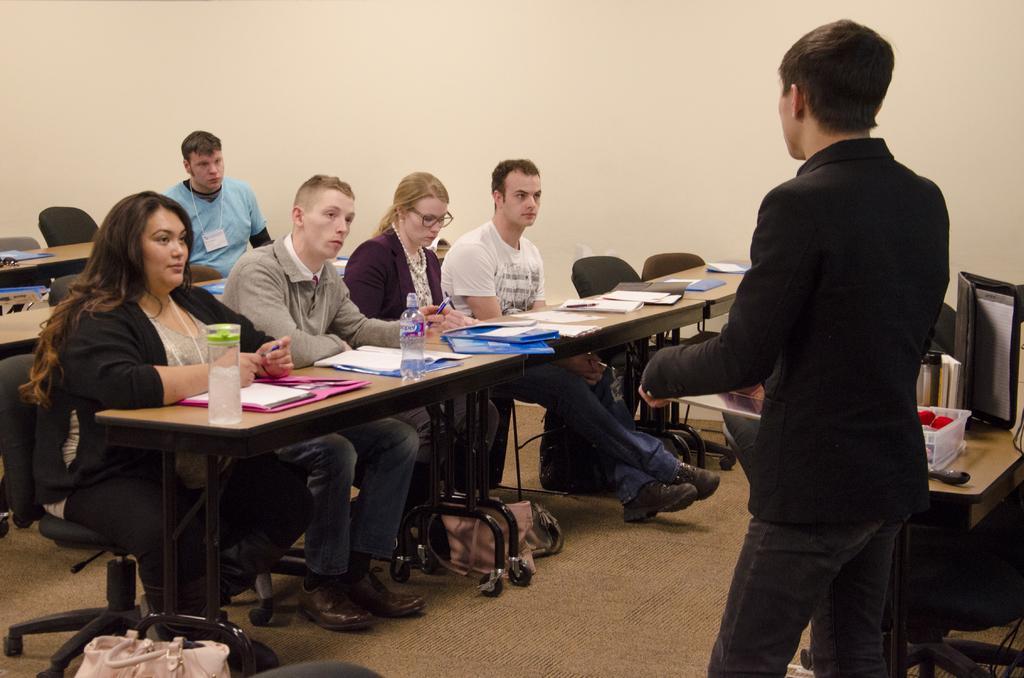Please provide a concise description of this image. This image is taken indoors. In the background there is a wall. At the bottom of the image there is a mat on the floor. In the middle of the image three men and two women are sitting on the chairs and there are a few benches with many things on them. There is a handbag on the floor. On the right side of the image there is a table with a few things on it and a man is standing on the floor. 